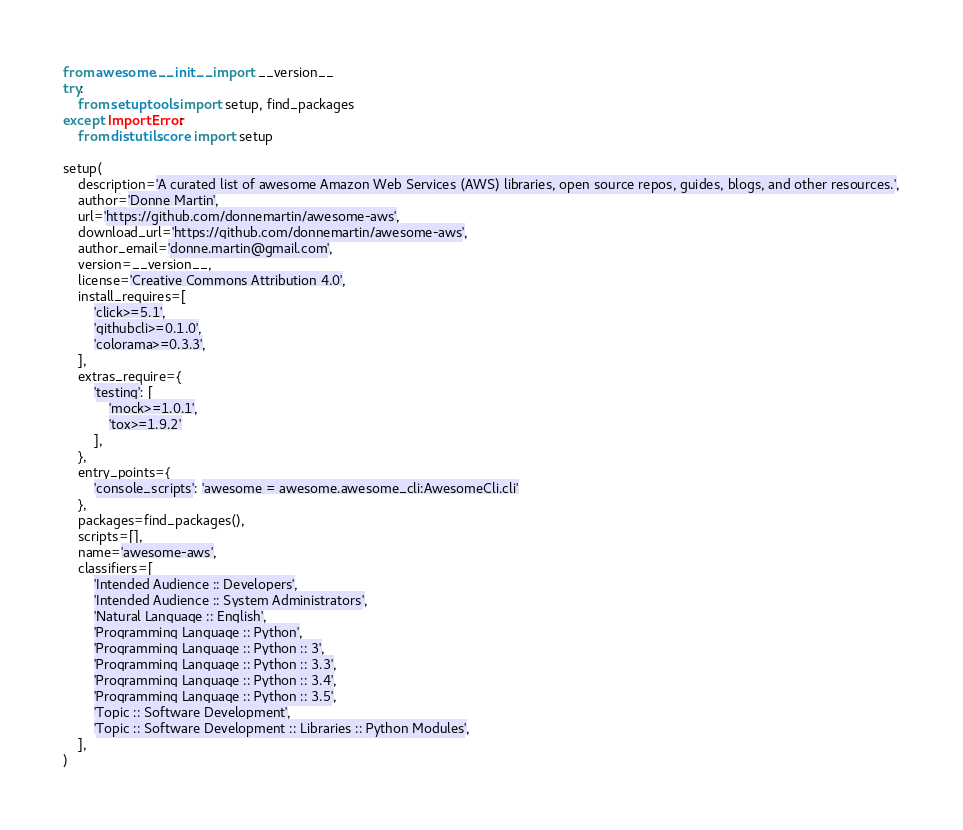<code> <loc_0><loc_0><loc_500><loc_500><_Python_>from awesome.__init__ import __version__
try:
    from setuptools import setup, find_packages
except ImportError:
    from distutils.core import setup

setup(
    description='A curated list of awesome Amazon Web Services (AWS) libraries, open source repos, guides, blogs, and other resources.',
    author='Donne Martin',
    url='https://github.com/donnemartin/awesome-aws',
    download_url='https://github.com/donnemartin/awesome-aws',
    author_email='donne.martin@gmail.com',
    version=__version__,
    license='Creative Commons Attribution 4.0',
    install_requires=[
        'click>=5.1',
        'githubcli>=0.1.0',
        'colorama>=0.3.3',
    ],
    extras_require={
        'testing': [
            'mock>=1.0.1',
            'tox>=1.9.2'
        ],
    },
    entry_points={
        'console_scripts': 'awesome = awesome.awesome_cli:AwesomeCli.cli'
    },
    packages=find_packages(),
    scripts=[],
    name='awesome-aws',
    classifiers=[
        'Intended Audience :: Developers',
        'Intended Audience :: System Administrators',
        'Natural Language :: English',
        'Programming Language :: Python',
        'Programming Language :: Python :: 3',
        'Programming Language :: Python :: 3.3',
        'Programming Language :: Python :: 3.4',
        'Programming Language :: Python :: 3.5',
        'Topic :: Software Development',
        'Topic :: Software Development :: Libraries :: Python Modules',
    ],
)
</code> 